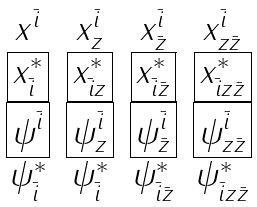<formula> <loc_0><loc_0><loc_500><loc_500>\begin{array} { c c c c } x ^ { \bar { i } } & x ^ { \bar { i } } _ { z } & x ^ { \bar { i } } _ { \bar { z } } & x ^ { \bar { i } } _ { z \bar { z } } \\ \boxed { x _ { \bar { i } } ^ { * } } & \boxed { x _ { \bar { i } z } ^ { * } } & \boxed { x _ { \bar { i } \bar { z } } ^ { * } } & \boxed { x _ { \bar { i } z \bar { z } } ^ { * } } \\ \boxed { \psi ^ { \bar { i } } } & \boxed { \psi ^ { \bar { i } } _ { z } } & \boxed { \psi ^ { \bar { i } } _ { \bar { z } } } & \boxed { \psi ^ { \bar { i } } _ { z \bar { z } } } \\ \psi _ { \bar { i } } ^ { * } & \psi _ { \bar { i } } ^ { * } & \psi _ { \bar { i } \bar { z } } ^ { * } & \psi _ { \bar { i } z \bar { z } } ^ { * } \end{array}</formula> 